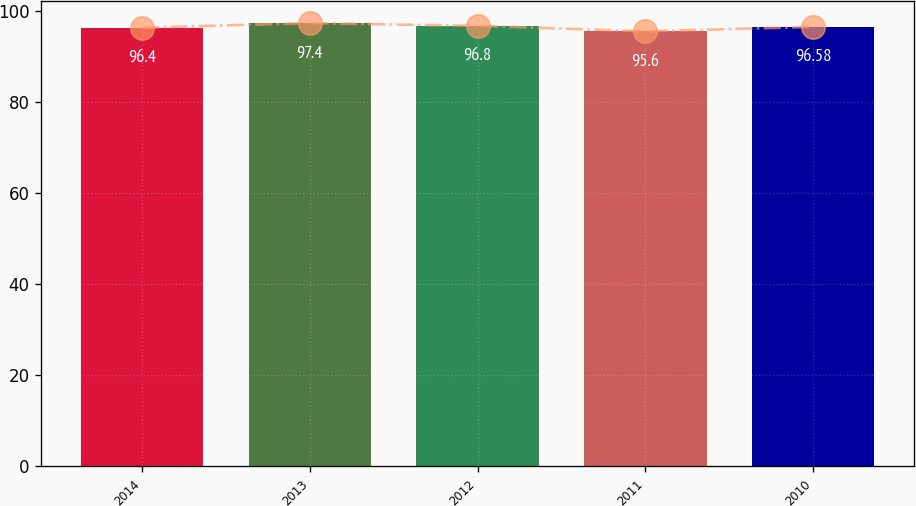Convert chart to OTSL. <chart><loc_0><loc_0><loc_500><loc_500><bar_chart><fcel>2014<fcel>2013<fcel>2012<fcel>2011<fcel>2010<nl><fcel>96.4<fcel>97.4<fcel>96.8<fcel>95.6<fcel>96.58<nl></chart> 